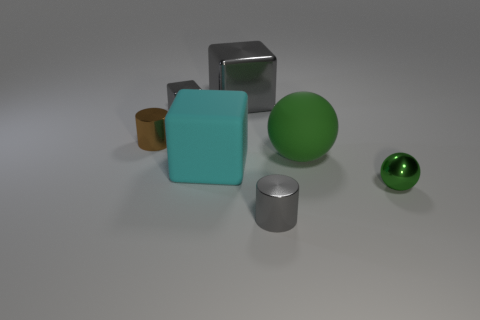What size is the metal cylinder that is the same color as the large shiny object?
Your answer should be compact. Small. What number of things are either gray blocks or spheres that are behind the rubber block?
Keep it short and to the point. 3. There is a cylinder behind the tiny green metallic sphere; does it have the same size as the cyan matte cube behind the small green metal thing?
Your response must be concise. No. Is there a large object made of the same material as the large ball?
Your response must be concise. Yes. The tiny brown shiny thing is what shape?
Offer a terse response. Cylinder. There is a big object behind the green object on the left side of the small green shiny object; what shape is it?
Offer a terse response. Cube. What number of other things are there of the same shape as the brown thing?
Your answer should be compact. 1. How big is the green object that is to the left of the tiny metallic object right of the large green object?
Offer a terse response. Large. Are any green metallic balls visible?
Your answer should be compact. Yes. What number of small things are in front of the metal object that is on the right side of the rubber sphere?
Your answer should be very brief. 1. 